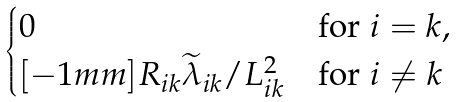<formula> <loc_0><loc_0><loc_500><loc_500>\begin{cases} 0 & \text {for} \ i = k , \\ [ - 1 m m ] R _ { i k } \widetilde { \lambda } _ { i k } / L _ { i k } ^ { 2 } & \text {for} \ i \neq k \end{cases}</formula> 